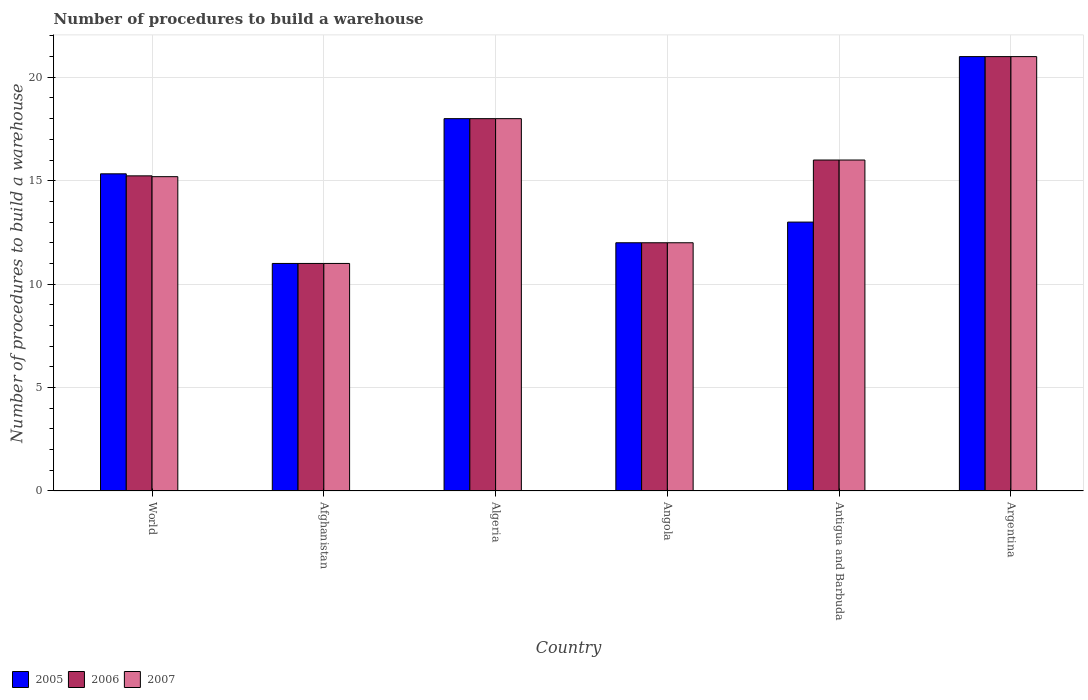Are the number of bars on each tick of the X-axis equal?
Offer a very short reply. Yes. How many bars are there on the 5th tick from the left?
Offer a terse response. 3. What is the number of procedures to build a warehouse in in 2006 in Antigua and Barbuda?
Offer a very short reply. 16. Across all countries, what is the minimum number of procedures to build a warehouse in in 2005?
Provide a succinct answer. 11. In which country was the number of procedures to build a warehouse in in 2005 minimum?
Your response must be concise. Afghanistan. What is the total number of procedures to build a warehouse in in 2005 in the graph?
Give a very brief answer. 90.33. What is the difference between the number of procedures to build a warehouse in in 2006 in Afghanistan and the number of procedures to build a warehouse in in 2007 in Antigua and Barbuda?
Your answer should be very brief. -5. What is the average number of procedures to build a warehouse in in 2005 per country?
Offer a terse response. 15.06. In how many countries, is the number of procedures to build a warehouse in in 2007 greater than the average number of procedures to build a warehouse in in 2007 taken over all countries?
Give a very brief answer. 3. What does the 3rd bar from the left in Algeria represents?
Provide a short and direct response. 2007. Is it the case that in every country, the sum of the number of procedures to build a warehouse in in 2006 and number of procedures to build a warehouse in in 2007 is greater than the number of procedures to build a warehouse in in 2005?
Provide a succinct answer. Yes. How many bars are there?
Offer a very short reply. 18. Are all the bars in the graph horizontal?
Give a very brief answer. No. What is the difference between two consecutive major ticks on the Y-axis?
Make the answer very short. 5. How many legend labels are there?
Your answer should be compact. 3. How are the legend labels stacked?
Offer a very short reply. Horizontal. What is the title of the graph?
Your answer should be compact. Number of procedures to build a warehouse. Does "2000" appear as one of the legend labels in the graph?
Keep it short and to the point. No. What is the label or title of the X-axis?
Keep it short and to the point. Country. What is the label or title of the Y-axis?
Ensure brevity in your answer.  Number of procedures to build a warehouse. What is the Number of procedures to build a warehouse in 2005 in World?
Provide a short and direct response. 15.33. What is the Number of procedures to build a warehouse in 2006 in World?
Offer a very short reply. 15.23. What is the Number of procedures to build a warehouse of 2007 in World?
Your answer should be very brief. 15.2. What is the Number of procedures to build a warehouse in 2005 in Afghanistan?
Give a very brief answer. 11. What is the Number of procedures to build a warehouse in 2006 in Afghanistan?
Offer a terse response. 11. What is the Number of procedures to build a warehouse of 2007 in Afghanistan?
Make the answer very short. 11. What is the Number of procedures to build a warehouse of 2006 in Algeria?
Your answer should be compact. 18. What is the Number of procedures to build a warehouse in 2005 in Angola?
Your answer should be compact. 12. What is the Number of procedures to build a warehouse of 2006 in Angola?
Keep it short and to the point. 12. What is the Number of procedures to build a warehouse in 2005 in Antigua and Barbuda?
Provide a short and direct response. 13. What is the Number of procedures to build a warehouse in 2007 in Antigua and Barbuda?
Your answer should be very brief. 16. What is the Number of procedures to build a warehouse in 2005 in Argentina?
Offer a very short reply. 21. What is the Number of procedures to build a warehouse in 2006 in Argentina?
Your answer should be compact. 21. Across all countries, what is the maximum Number of procedures to build a warehouse of 2005?
Your response must be concise. 21. Across all countries, what is the minimum Number of procedures to build a warehouse of 2005?
Provide a succinct answer. 11. Across all countries, what is the minimum Number of procedures to build a warehouse in 2006?
Make the answer very short. 11. What is the total Number of procedures to build a warehouse of 2005 in the graph?
Keep it short and to the point. 90.33. What is the total Number of procedures to build a warehouse in 2006 in the graph?
Give a very brief answer. 93.23. What is the total Number of procedures to build a warehouse in 2007 in the graph?
Keep it short and to the point. 93.2. What is the difference between the Number of procedures to build a warehouse in 2005 in World and that in Afghanistan?
Ensure brevity in your answer.  4.33. What is the difference between the Number of procedures to build a warehouse in 2006 in World and that in Afghanistan?
Give a very brief answer. 4.23. What is the difference between the Number of procedures to build a warehouse in 2007 in World and that in Afghanistan?
Provide a short and direct response. 4.2. What is the difference between the Number of procedures to build a warehouse of 2005 in World and that in Algeria?
Make the answer very short. -2.67. What is the difference between the Number of procedures to build a warehouse of 2006 in World and that in Algeria?
Provide a succinct answer. -2.77. What is the difference between the Number of procedures to build a warehouse in 2007 in World and that in Algeria?
Your response must be concise. -2.8. What is the difference between the Number of procedures to build a warehouse of 2005 in World and that in Angola?
Your answer should be very brief. 3.33. What is the difference between the Number of procedures to build a warehouse in 2006 in World and that in Angola?
Provide a succinct answer. 3.23. What is the difference between the Number of procedures to build a warehouse in 2007 in World and that in Angola?
Offer a terse response. 3.2. What is the difference between the Number of procedures to build a warehouse in 2005 in World and that in Antigua and Barbuda?
Provide a short and direct response. 2.33. What is the difference between the Number of procedures to build a warehouse of 2006 in World and that in Antigua and Barbuda?
Provide a succinct answer. -0.77. What is the difference between the Number of procedures to build a warehouse of 2007 in World and that in Antigua and Barbuda?
Your answer should be very brief. -0.8. What is the difference between the Number of procedures to build a warehouse of 2005 in World and that in Argentina?
Make the answer very short. -5.67. What is the difference between the Number of procedures to build a warehouse in 2006 in World and that in Argentina?
Provide a short and direct response. -5.77. What is the difference between the Number of procedures to build a warehouse of 2007 in World and that in Argentina?
Offer a terse response. -5.8. What is the difference between the Number of procedures to build a warehouse in 2007 in Afghanistan and that in Angola?
Give a very brief answer. -1. What is the difference between the Number of procedures to build a warehouse of 2006 in Afghanistan and that in Antigua and Barbuda?
Your answer should be very brief. -5. What is the difference between the Number of procedures to build a warehouse in 2007 in Afghanistan and that in Antigua and Barbuda?
Keep it short and to the point. -5. What is the difference between the Number of procedures to build a warehouse in 2005 in Afghanistan and that in Argentina?
Provide a succinct answer. -10. What is the difference between the Number of procedures to build a warehouse of 2007 in Afghanistan and that in Argentina?
Keep it short and to the point. -10. What is the difference between the Number of procedures to build a warehouse in 2005 in Algeria and that in Angola?
Your answer should be compact. 6. What is the difference between the Number of procedures to build a warehouse of 2007 in Algeria and that in Angola?
Your response must be concise. 6. What is the difference between the Number of procedures to build a warehouse of 2005 in Algeria and that in Argentina?
Your response must be concise. -3. What is the difference between the Number of procedures to build a warehouse of 2006 in Algeria and that in Argentina?
Ensure brevity in your answer.  -3. What is the difference between the Number of procedures to build a warehouse in 2007 in Algeria and that in Argentina?
Give a very brief answer. -3. What is the difference between the Number of procedures to build a warehouse of 2005 in Angola and that in Antigua and Barbuda?
Ensure brevity in your answer.  -1. What is the difference between the Number of procedures to build a warehouse in 2006 in Angola and that in Antigua and Barbuda?
Your answer should be compact. -4. What is the difference between the Number of procedures to build a warehouse of 2005 in Antigua and Barbuda and that in Argentina?
Your answer should be compact. -8. What is the difference between the Number of procedures to build a warehouse in 2005 in World and the Number of procedures to build a warehouse in 2006 in Afghanistan?
Keep it short and to the point. 4.33. What is the difference between the Number of procedures to build a warehouse of 2005 in World and the Number of procedures to build a warehouse of 2007 in Afghanistan?
Offer a very short reply. 4.33. What is the difference between the Number of procedures to build a warehouse in 2006 in World and the Number of procedures to build a warehouse in 2007 in Afghanistan?
Ensure brevity in your answer.  4.23. What is the difference between the Number of procedures to build a warehouse of 2005 in World and the Number of procedures to build a warehouse of 2006 in Algeria?
Offer a terse response. -2.67. What is the difference between the Number of procedures to build a warehouse in 2005 in World and the Number of procedures to build a warehouse in 2007 in Algeria?
Make the answer very short. -2.67. What is the difference between the Number of procedures to build a warehouse of 2006 in World and the Number of procedures to build a warehouse of 2007 in Algeria?
Give a very brief answer. -2.77. What is the difference between the Number of procedures to build a warehouse in 2005 in World and the Number of procedures to build a warehouse in 2006 in Angola?
Your answer should be very brief. 3.33. What is the difference between the Number of procedures to build a warehouse in 2006 in World and the Number of procedures to build a warehouse in 2007 in Angola?
Keep it short and to the point. 3.23. What is the difference between the Number of procedures to build a warehouse in 2005 in World and the Number of procedures to build a warehouse in 2006 in Antigua and Barbuda?
Keep it short and to the point. -0.67. What is the difference between the Number of procedures to build a warehouse of 2005 in World and the Number of procedures to build a warehouse of 2007 in Antigua and Barbuda?
Offer a very short reply. -0.67. What is the difference between the Number of procedures to build a warehouse in 2006 in World and the Number of procedures to build a warehouse in 2007 in Antigua and Barbuda?
Your answer should be compact. -0.77. What is the difference between the Number of procedures to build a warehouse of 2005 in World and the Number of procedures to build a warehouse of 2006 in Argentina?
Your answer should be compact. -5.67. What is the difference between the Number of procedures to build a warehouse of 2005 in World and the Number of procedures to build a warehouse of 2007 in Argentina?
Your answer should be very brief. -5.67. What is the difference between the Number of procedures to build a warehouse of 2006 in World and the Number of procedures to build a warehouse of 2007 in Argentina?
Make the answer very short. -5.77. What is the difference between the Number of procedures to build a warehouse of 2005 in Afghanistan and the Number of procedures to build a warehouse of 2006 in Algeria?
Make the answer very short. -7. What is the difference between the Number of procedures to build a warehouse of 2005 in Afghanistan and the Number of procedures to build a warehouse of 2007 in Algeria?
Your answer should be compact. -7. What is the difference between the Number of procedures to build a warehouse of 2005 in Afghanistan and the Number of procedures to build a warehouse of 2007 in Angola?
Offer a terse response. -1. What is the difference between the Number of procedures to build a warehouse of 2006 in Afghanistan and the Number of procedures to build a warehouse of 2007 in Angola?
Offer a terse response. -1. What is the difference between the Number of procedures to build a warehouse of 2005 in Afghanistan and the Number of procedures to build a warehouse of 2006 in Antigua and Barbuda?
Ensure brevity in your answer.  -5. What is the difference between the Number of procedures to build a warehouse of 2006 in Afghanistan and the Number of procedures to build a warehouse of 2007 in Antigua and Barbuda?
Offer a terse response. -5. What is the difference between the Number of procedures to build a warehouse of 2006 in Afghanistan and the Number of procedures to build a warehouse of 2007 in Argentina?
Offer a terse response. -10. What is the difference between the Number of procedures to build a warehouse in 2005 in Algeria and the Number of procedures to build a warehouse in 2006 in Angola?
Your response must be concise. 6. What is the difference between the Number of procedures to build a warehouse in 2005 in Algeria and the Number of procedures to build a warehouse in 2006 in Antigua and Barbuda?
Keep it short and to the point. 2. What is the difference between the Number of procedures to build a warehouse in 2006 in Algeria and the Number of procedures to build a warehouse in 2007 in Antigua and Barbuda?
Ensure brevity in your answer.  2. What is the difference between the Number of procedures to build a warehouse of 2006 in Algeria and the Number of procedures to build a warehouse of 2007 in Argentina?
Your response must be concise. -3. What is the difference between the Number of procedures to build a warehouse of 2005 in Antigua and Barbuda and the Number of procedures to build a warehouse of 2006 in Argentina?
Offer a terse response. -8. What is the average Number of procedures to build a warehouse of 2005 per country?
Keep it short and to the point. 15.06. What is the average Number of procedures to build a warehouse of 2006 per country?
Give a very brief answer. 15.54. What is the average Number of procedures to build a warehouse of 2007 per country?
Keep it short and to the point. 15.53. What is the difference between the Number of procedures to build a warehouse in 2005 and Number of procedures to build a warehouse in 2006 in World?
Offer a very short reply. 0.1. What is the difference between the Number of procedures to build a warehouse of 2005 and Number of procedures to build a warehouse of 2007 in World?
Make the answer very short. 0.14. What is the difference between the Number of procedures to build a warehouse of 2006 and Number of procedures to build a warehouse of 2007 in World?
Keep it short and to the point. 0.04. What is the difference between the Number of procedures to build a warehouse in 2005 and Number of procedures to build a warehouse in 2007 in Afghanistan?
Keep it short and to the point. 0. What is the difference between the Number of procedures to build a warehouse in 2006 and Number of procedures to build a warehouse in 2007 in Afghanistan?
Make the answer very short. 0. What is the difference between the Number of procedures to build a warehouse in 2005 and Number of procedures to build a warehouse in 2006 in Angola?
Make the answer very short. 0. What is the difference between the Number of procedures to build a warehouse of 2005 and Number of procedures to build a warehouse of 2007 in Angola?
Provide a succinct answer. 0. What is the difference between the Number of procedures to build a warehouse of 2006 and Number of procedures to build a warehouse of 2007 in Angola?
Offer a terse response. 0. What is the difference between the Number of procedures to build a warehouse of 2005 and Number of procedures to build a warehouse of 2006 in Argentina?
Offer a terse response. 0. What is the difference between the Number of procedures to build a warehouse of 2005 and Number of procedures to build a warehouse of 2007 in Argentina?
Make the answer very short. 0. What is the ratio of the Number of procedures to build a warehouse in 2005 in World to that in Afghanistan?
Ensure brevity in your answer.  1.39. What is the ratio of the Number of procedures to build a warehouse in 2006 in World to that in Afghanistan?
Provide a short and direct response. 1.39. What is the ratio of the Number of procedures to build a warehouse of 2007 in World to that in Afghanistan?
Ensure brevity in your answer.  1.38. What is the ratio of the Number of procedures to build a warehouse in 2005 in World to that in Algeria?
Provide a succinct answer. 0.85. What is the ratio of the Number of procedures to build a warehouse in 2006 in World to that in Algeria?
Offer a very short reply. 0.85. What is the ratio of the Number of procedures to build a warehouse of 2007 in World to that in Algeria?
Provide a succinct answer. 0.84. What is the ratio of the Number of procedures to build a warehouse of 2005 in World to that in Angola?
Keep it short and to the point. 1.28. What is the ratio of the Number of procedures to build a warehouse of 2006 in World to that in Angola?
Your answer should be compact. 1.27. What is the ratio of the Number of procedures to build a warehouse of 2007 in World to that in Angola?
Your answer should be compact. 1.27. What is the ratio of the Number of procedures to build a warehouse of 2005 in World to that in Antigua and Barbuda?
Provide a succinct answer. 1.18. What is the ratio of the Number of procedures to build a warehouse of 2006 in World to that in Antigua and Barbuda?
Keep it short and to the point. 0.95. What is the ratio of the Number of procedures to build a warehouse in 2007 in World to that in Antigua and Barbuda?
Your response must be concise. 0.95. What is the ratio of the Number of procedures to build a warehouse in 2005 in World to that in Argentina?
Offer a very short reply. 0.73. What is the ratio of the Number of procedures to build a warehouse of 2006 in World to that in Argentina?
Make the answer very short. 0.73. What is the ratio of the Number of procedures to build a warehouse in 2007 in World to that in Argentina?
Your answer should be very brief. 0.72. What is the ratio of the Number of procedures to build a warehouse of 2005 in Afghanistan to that in Algeria?
Make the answer very short. 0.61. What is the ratio of the Number of procedures to build a warehouse of 2006 in Afghanistan to that in Algeria?
Ensure brevity in your answer.  0.61. What is the ratio of the Number of procedures to build a warehouse of 2007 in Afghanistan to that in Algeria?
Your answer should be compact. 0.61. What is the ratio of the Number of procedures to build a warehouse in 2007 in Afghanistan to that in Angola?
Provide a succinct answer. 0.92. What is the ratio of the Number of procedures to build a warehouse of 2005 in Afghanistan to that in Antigua and Barbuda?
Keep it short and to the point. 0.85. What is the ratio of the Number of procedures to build a warehouse of 2006 in Afghanistan to that in Antigua and Barbuda?
Ensure brevity in your answer.  0.69. What is the ratio of the Number of procedures to build a warehouse in 2007 in Afghanistan to that in Antigua and Barbuda?
Provide a succinct answer. 0.69. What is the ratio of the Number of procedures to build a warehouse of 2005 in Afghanistan to that in Argentina?
Ensure brevity in your answer.  0.52. What is the ratio of the Number of procedures to build a warehouse in 2006 in Afghanistan to that in Argentina?
Give a very brief answer. 0.52. What is the ratio of the Number of procedures to build a warehouse in 2007 in Afghanistan to that in Argentina?
Give a very brief answer. 0.52. What is the ratio of the Number of procedures to build a warehouse of 2005 in Algeria to that in Angola?
Offer a terse response. 1.5. What is the ratio of the Number of procedures to build a warehouse of 2007 in Algeria to that in Angola?
Provide a succinct answer. 1.5. What is the ratio of the Number of procedures to build a warehouse in 2005 in Algeria to that in Antigua and Barbuda?
Offer a terse response. 1.38. What is the ratio of the Number of procedures to build a warehouse of 2007 in Algeria to that in Antigua and Barbuda?
Provide a succinct answer. 1.12. What is the ratio of the Number of procedures to build a warehouse in 2006 in Angola to that in Antigua and Barbuda?
Offer a very short reply. 0.75. What is the ratio of the Number of procedures to build a warehouse of 2007 in Angola to that in Antigua and Barbuda?
Make the answer very short. 0.75. What is the ratio of the Number of procedures to build a warehouse of 2005 in Angola to that in Argentina?
Offer a terse response. 0.57. What is the ratio of the Number of procedures to build a warehouse of 2006 in Angola to that in Argentina?
Your answer should be very brief. 0.57. What is the ratio of the Number of procedures to build a warehouse in 2005 in Antigua and Barbuda to that in Argentina?
Keep it short and to the point. 0.62. What is the ratio of the Number of procedures to build a warehouse in 2006 in Antigua and Barbuda to that in Argentina?
Keep it short and to the point. 0.76. What is the ratio of the Number of procedures to build a warehouse of 2007 in Antigua and Barbuda to that in Argentina?
Your response must be concise. 0.76. What is the difference between the highest and the second highest Number of procedures to build a warehouse in 2006?
Provide a short and direct response. 3. What is the difference between the highest and the lowest Number of procedures to build a warehouse of 2005?
Offer a terse response. 10. 